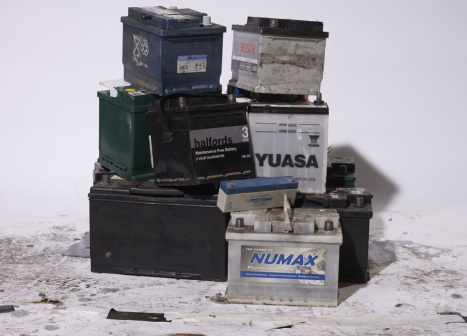Analyze the image in a comprehensive and detailed manner. The image showcases a cluster of old car batteries, visibly worn and weathered. In the foreground, nine batteries are arranged haphazardly, varying in colors such as black, green, and blue. These batteries differ in size, implying they could originate from various models of vehicles.

Of the batteries, four are situated directly on the ground, while the remaining five are stacked precariously on top, forming an unsteady tower. Each battery is labeled; some visible names include ‘Halfords 3’, ‘YUASA’, and ‘NUMAX’.

A stark white wall in the background contrasts sharply with the colorful batteries, while dirt and debris scattered on the ground indicate an outdoor setting. The scene appears to be a collection point for used car batteries, likely intended for recycling or disposal. 